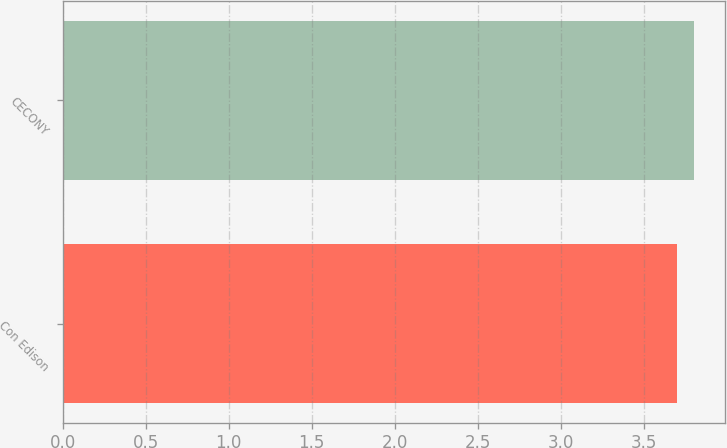Convert chart. <chart><loc_0><loc_0><loc_500><loc_500><bar_chart><fcel>Con Edison<fcel>CECONY<nl><fcel>3.7<fcel>3.8<nl></chart> 